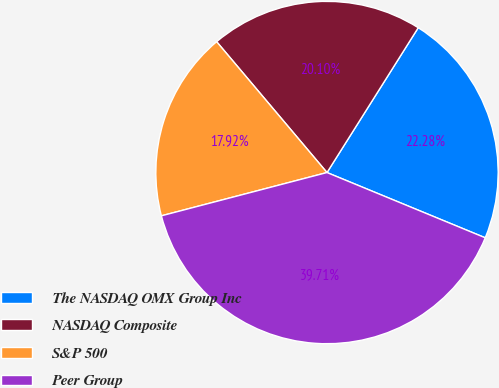<chart> <loc_0><loc_0><loc_500><loc_500><pie_chart><fcel>The NASDAQ OMX Group Inc<fcel>NASDAQ Composite<fcel>S&P 500<fcel>Peer Group<nl><fcel>22.28%<fcel>20.1%<fcel>17.92%<fcel>39.71%<nl></chart> 